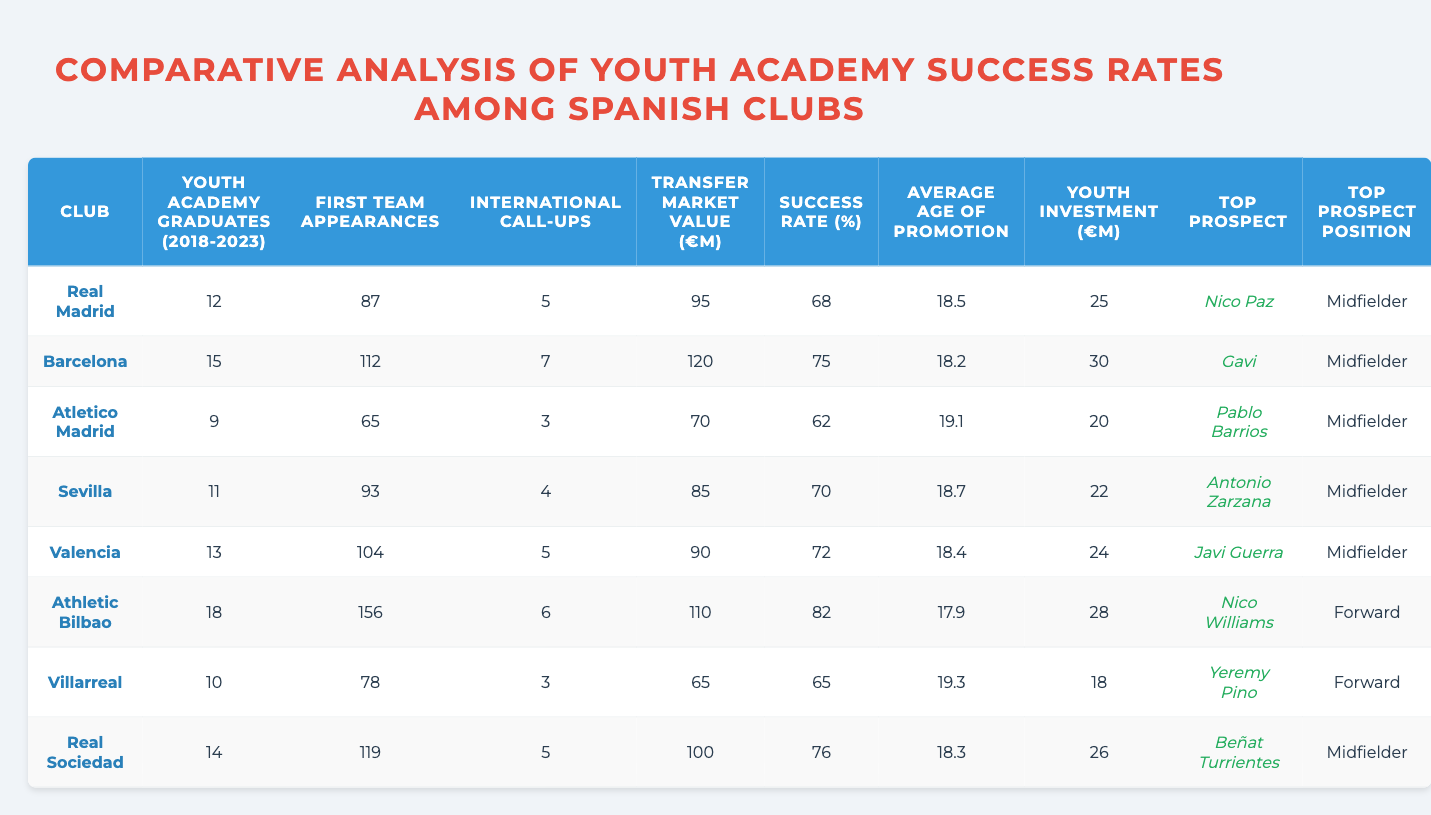What club had the highest number of youth academy graduates from 2018 to 2023? The highest number of youth academy graduates is 18, which corresponds to Athletic Bilbao.
Answer: Athletic Bilbao Which club had the lowest transfer market value among the listed clubs? The lowest transfer market value is 65 million euros, which belongs to Villarreal.
Answer: Villarreal What is the average success rate of the clubs listed in the table? First, we sum the success rates: 68 + 75 + 62 + 70 + 72 + 82 + 65 + 76 = 600. Then, we divide by the number of clubs (8), resulting in an average of 600/8 = 75%.
Answer: 75% Did Real Madrid have more international call-ups than Sevilla? Real Madrid had 5 international call-ups while Sevilla had 4, so Real Madrid did have more.
Answer: Yes Which club had the highest success rate and what was it? The highest success rate was 82%, which corresponds to Athletic Bilbao.
Answer: 82% What is the average age of promotion for clubs with a success rate higher than 75%? The clubs with success rates higher than 75% are Barcelona (18.2), Athletic Bilbao (17.9), and Real Sociedad (18.3). Their average age of promotion is (18.2 + 17.9 + 18.3) / 3 = 18.13.
Answer: 18.13 Which club's top prospect plays as a Forward? The club with a top prospect playing as a Forward is Athletic Bilbao, with Nico Williams.
Answer: Athletic Bilbao Is there a club with more than 100 first team appearances among graduates? Yes, Barcelona, Atletico Madrid, Sevilla, Valencia, and Real Sociedad all had more than 100 first team appearances.
Answer: Yes What is the transfer market value of the club with the youngest average age of promotion? The club with the youngest average age of promotion is Athletic Bilbao (17.9), and their transfer market value is 110 million euros.
Answer: 110 million euros Identify the club that produced the most youth academy graduates but had the fewest first team appearances. Real Madrid produced 12 graduates but had 87 first team appearances; conversely, Atletico Madrid only produced 9 graduates but had 65 appearances. The club with the most graduates but the fewest appearances overall is Real Madrid.
Answer: Real Madrid 